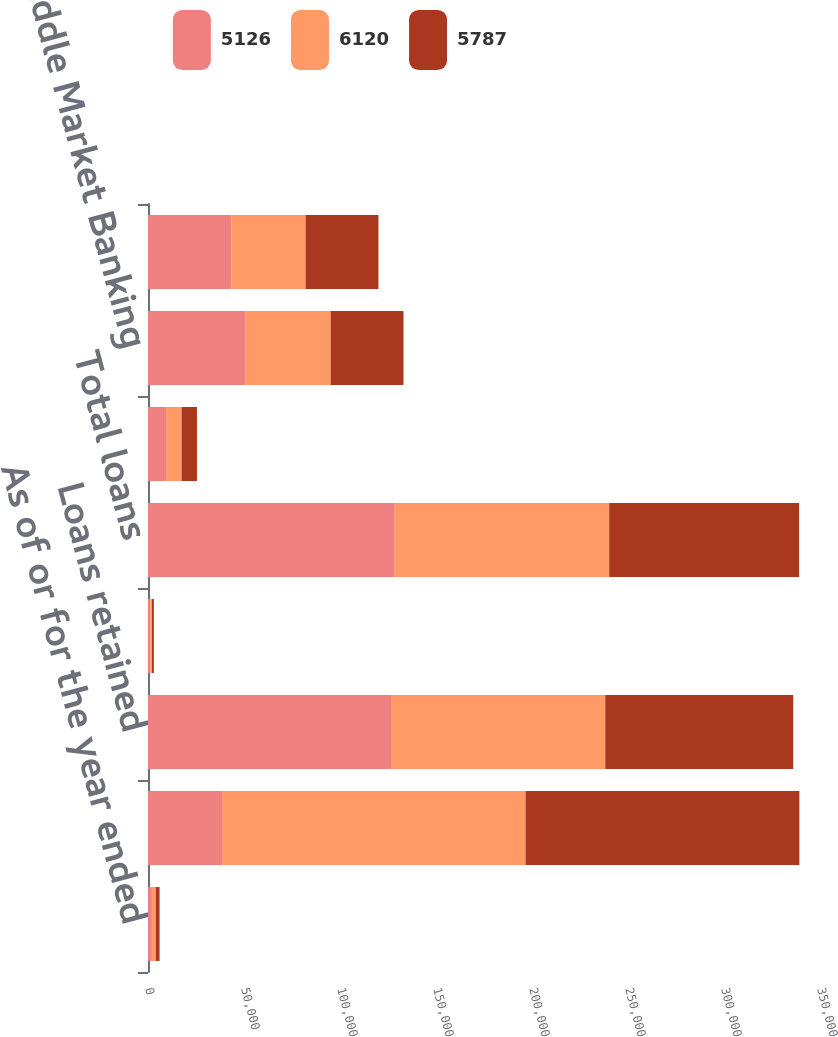Convert chart. <chart><loc_0><loc_0><loc_500><loc_500><stacked_bar_chart><ecel><fcel>As of or for the year ended<fcel>Total assets<fcel>Loans retained<fcel>Loans held-for-sale and loans<fcel>Total loans<fcel>Equity<fcel>Middle Market Banking<fcel>Commercial Term Lending<nl><fcel>5126<fcel>2012<fcel>38583<fcel>126996<fcel>1212<fcel>128208<fcel>9500<fcel>50701<fcel>43512<nl><fcel>6120<fcel>2011<fcel>158040<fcel>111162<fcel>840<fcel>112002<fcel>8000<fcel>44437<fcel>38583<nl><fcel>5787<fcel>2010<fcel>142646<fcel>97900<fcel>1018<fcel>98918<fcel>8000<fcel>37942<fcel>37928<nl></chart> 